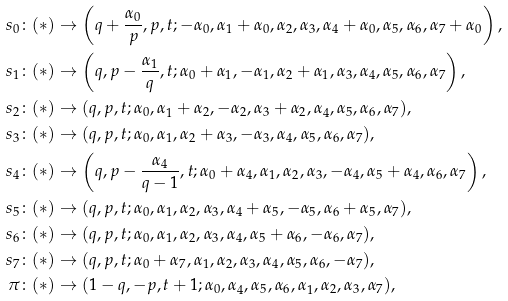Convert formula to latex. <formula><loc_0><loc_0><loc_500><loc_500>s _ { 0 } \colon ( * ) & \rightarrow \left ( q + \frac { \alpha _ { 0 } } { p } , p , t ; - \alpha _ { 0 } , \alpha _ { 1 } + \alpha _ { 0 } , \alpha _ { 2 } , \alpha _ { 3 } , \alpha _ { 4 } + \alpha _ { 0 } , \alpha _ { 5 } , \alpha _ { 6 } , \alpha _ { 7 } + \alpha _ { 0 } \right ) , \\ s _ { 1 } \colon ( * ) & \rightarrow \left ( q , p - \frac { \alpha _ { 1 } } { q } , t ; \alpha _ { 0 } + \alpha _ { 1 } , - \alpha _ { 1 } , \alpha _ { 2 } + \alpha _ { 1 } , \alpha _ { 3 } , \alpha _ { 4 } , \alpha _ { 5 } , \alpha _ { 6 } , \alpha _ { 7 } \right ) , \\ s _ { 2 } \colon ( * ) & \rightarrow ( q , p , t ; \alpha _ { 0 } , \alpha _ { 1 } + \alpha _ { 2 } , - \alpha _ { 2 } , \alpha _ { 3 } + \alpha _ { 2 } , \alpha _ { 4 } , \alpha _ { 5 } , \alpha _ { 6 } , \alpha _ { 7 } ) , \\ s _ { 3 } \colon ( * ) & \rightarrow ( q , p , t ; \alpha _ { 0 } , \alpha _ { 1 } , \alpha _ { 2 } + \alpha _ { 3 } , - \alpha _ { 3 } , \alpha _ { 4 } , \alpha _ { 5 } , \alpha _ { 6 } , \alpha _ { 7 } ) , \\ s _ { 4 } \colon ( * ) & \rightarrow \left ( q , p - \frac { \alpha _ { 4 } } { q - 1 } , t ; \alpha _ { 0 } + \alpha _ { 4 } , \alpha _ { 1 } , \alpha _ { 2 } , \alpha _ { 3 } , - \alpha _ { 4 } , \alpha _ { 5 } + \alpha _ { 4 } , \alpha _ { 6 } , \alpha _ { 7 } \right ) , \\ s _ { 5 } \colon ( * ) & \rightarrow ( q , p , t ; \alpha _ { 0 } , \alpha _ { 1 } , \alpha _ { 2 } , \alpha _ { 3 } , \alpha _ { 4 } + \alpha _ { 5 } , - \alpha _ { 5 } , \alpha _ { 6 } + \alpha _ { 5 } , \alpha _ { 7 } ) , \\ s _ { 6 } \colon ( * ) & \rightarrow ( q , p , t ; \alpha _ { 0 } , \alpha _ { 1 } , \alpha _ { 2 } , \alpha _ { 3 } , \alpha _ { 4 } , \alpha _ { 5 } + \alpha _ { 6 } , - \alpha _ { 6 } , \alpha _ { 7 } ) , \\ s _ { 7 } \colon ( * ) & \rightarrow ( q , p , t ; \alpha _ { 0 } + \alpha _ { 7 } , \alpha _ { 1 } , \alpha _ { 2 } , \alpha _ { 3 } , \alpha _ { 4 } , \alpha _ { 5 } , \alpha _ { 6 } , - \alpha _ { 7 } ) , \\ \pi \colon ( * ) & \rightarrow ( 1 - q , - p , t + 1 ; \alpha _ { 0 } , \alpha _ { 4 } , \alpha _ { 5 } , \alpha _ { 6 } , \alpha _ { 1 } , \alpha _ { 2 } , \alpha _ { 3 } , \alpha _ { 7 } ) ,</formula> 